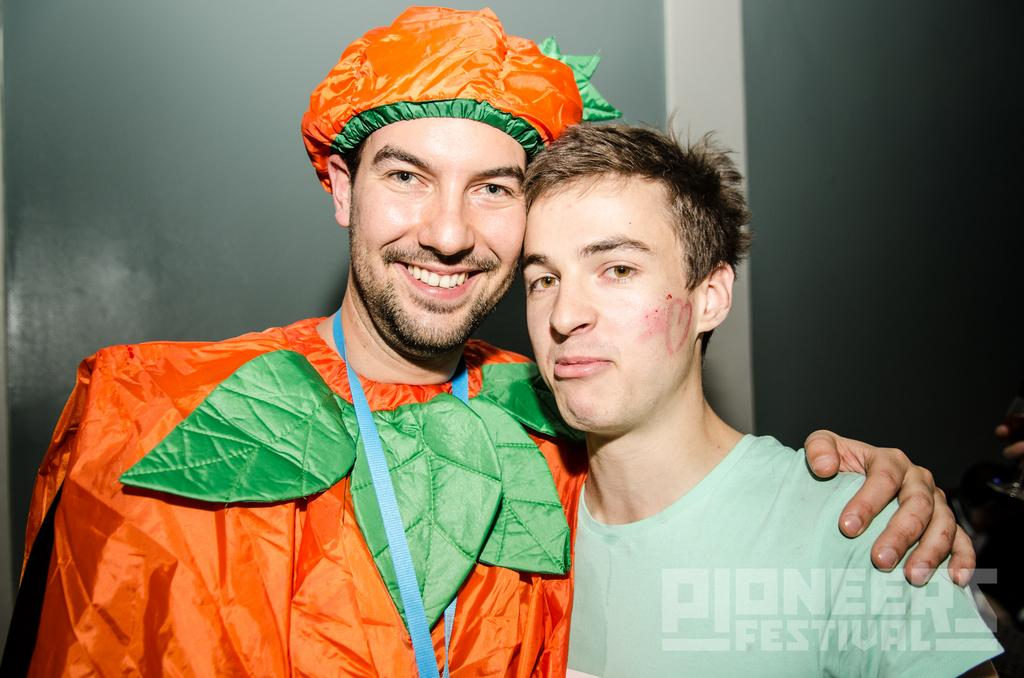How many people are in the image? There are people in the image, but the exact number is not specified. What is unique about the appearance of one of the people? One person is wearing a costume. What can be seen attached to the person in the costume? The person in the costume has an ID card. What can be seen in the background of the image? There is a wall in the background of the image. What is present at the bottom of the image? There is some text at the bottom of the image. What type of breakfast is being served in the image? There is no breakfast visible in the image. Can you see any sea creatures in the image? There is no mention of sea creatures or any marine environment in the image. 